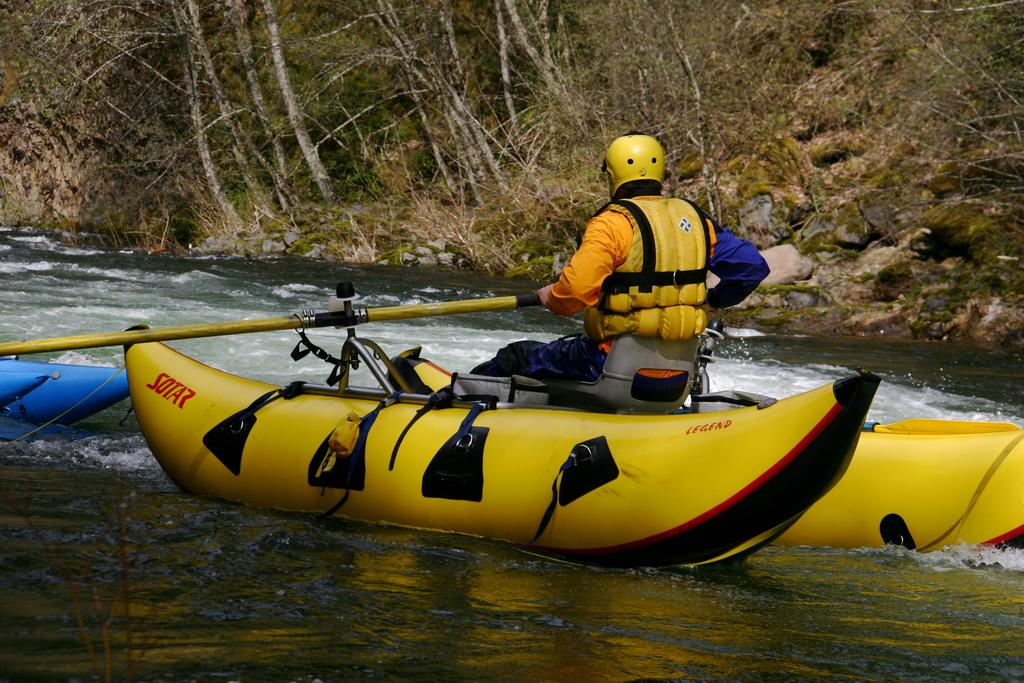<image>
Write a terse but informative summary of the picture. A man in a orange and blue shirt and yellow lifevest is rowing in a yellow banana-shaped raft 